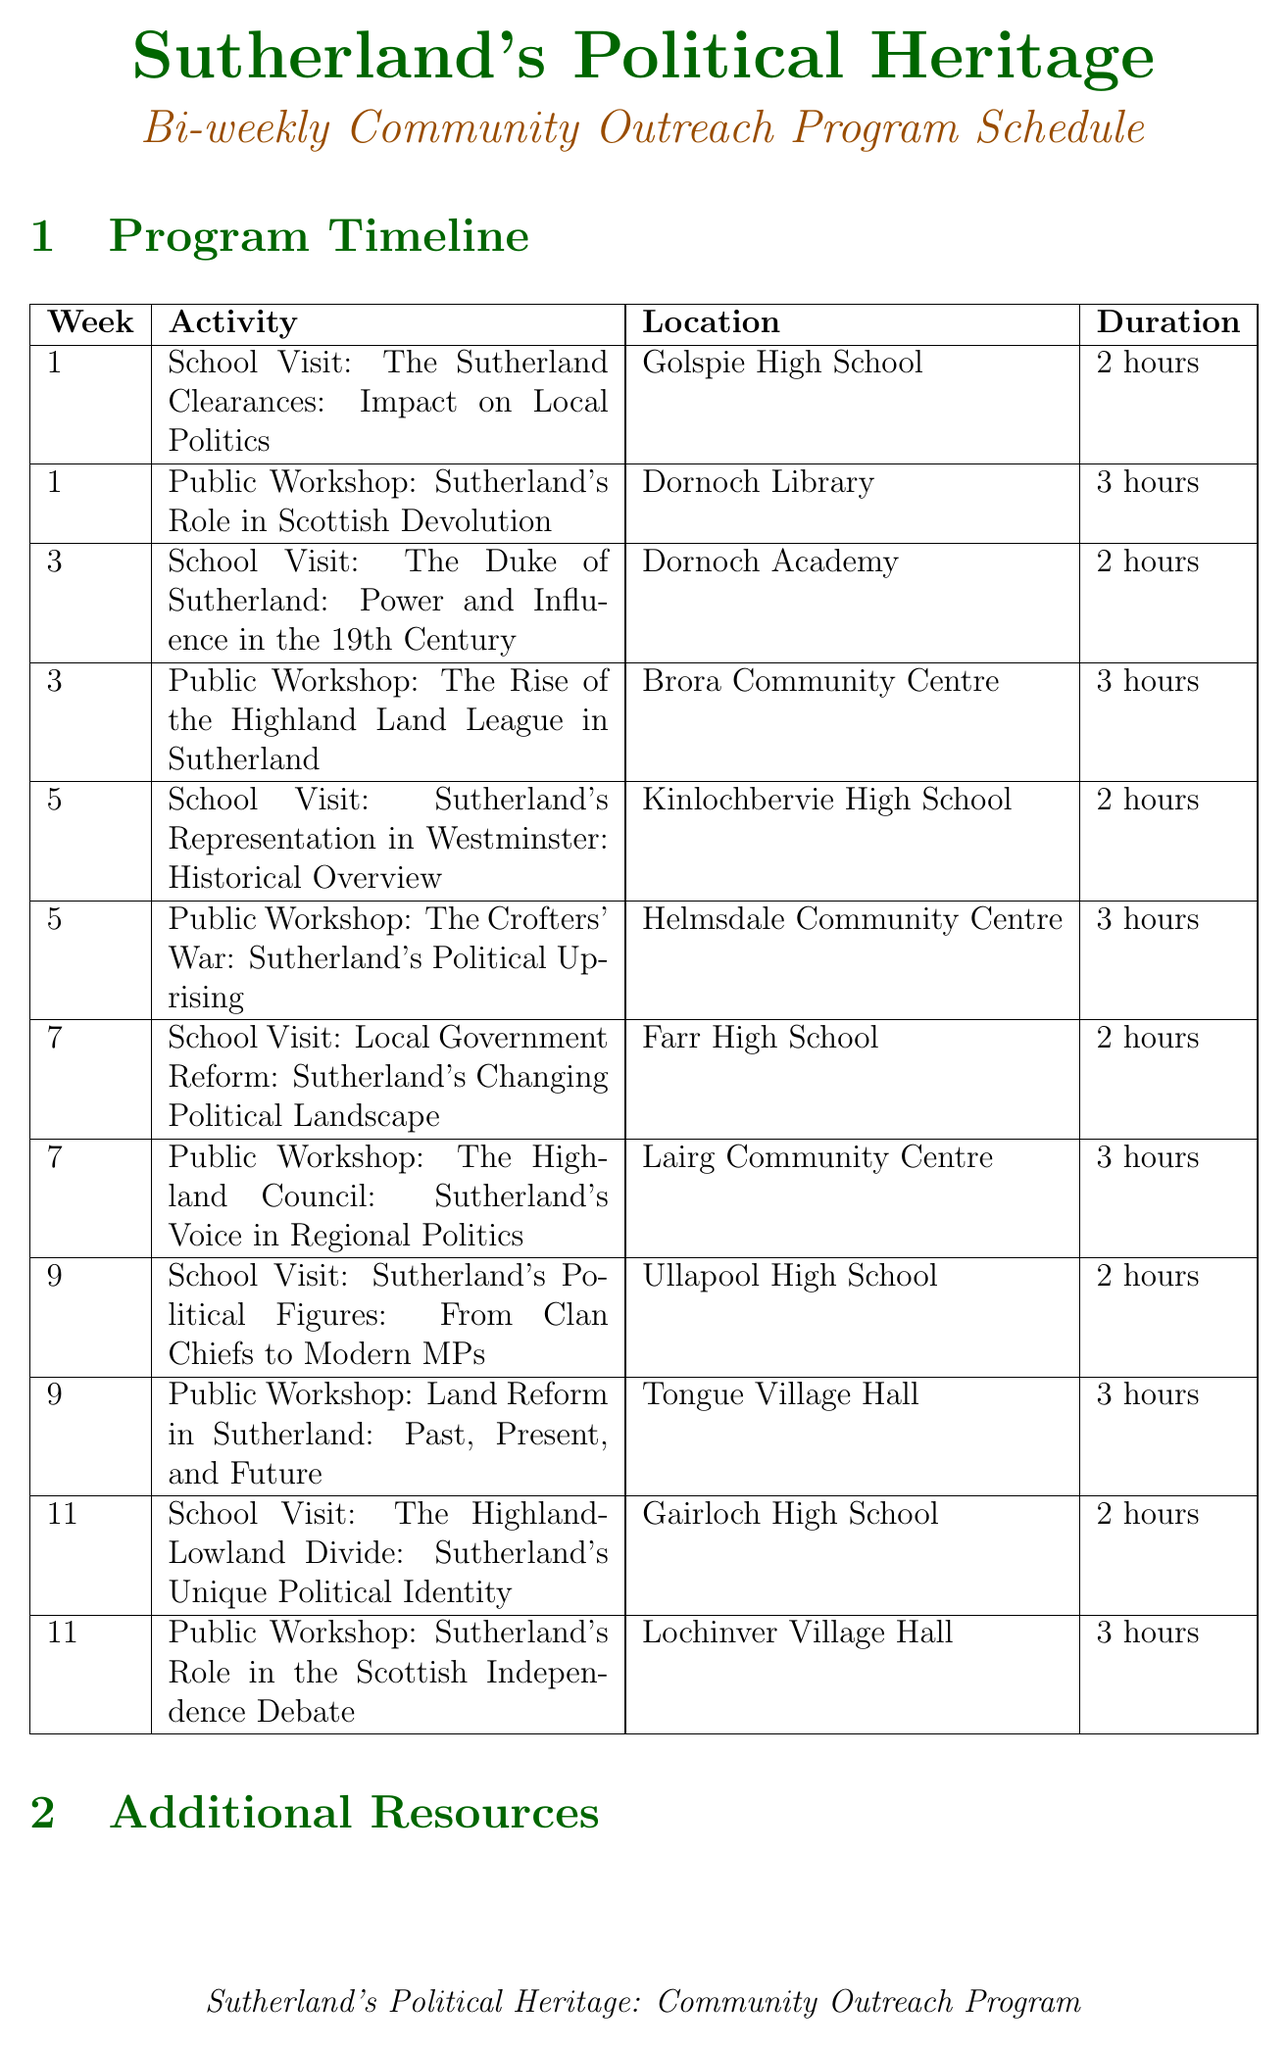what is the first school visit topic? The first school visit is about "The Sutherland Clearances: Impact on Local Politics".
Answer: The Sutherland Clearances: Impact on Local Politics how long does the public workshop in Dornoch Library last? The duration of the public workshop in Dornoch Library is 3 hours.
Answer: 3 hours what week is the guest lecture scheduled? The guest lecture by Dr. James Hunter is scheduled for week 6.
Answer: Week 6 which high school will have a visit focused on local government reform? The school visit focused on local government reform will be at Farr High School.
Answer: Farr High School how many hours are dedicated to school visits in total? There are a total of 12 hours dedicated to school visits, calculated as 2 hours per visit over 6 weeks.
Answer: 12 hours what is the location of the ongoing exhibition? The ongoing exhibition is located at Timespan Museum, Helmsdale.
Answer: Timespan Museum, Helmsdale which community center will host the workshop on the Highland Council? The Highland Council workshop will be held at Lairg Community Centre.
Answer: Lairg Community Centre how frequently do the field trips occur? The field trips occur once per month during the program.
Answer: Once per month 